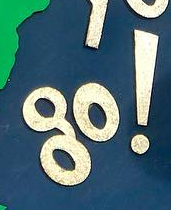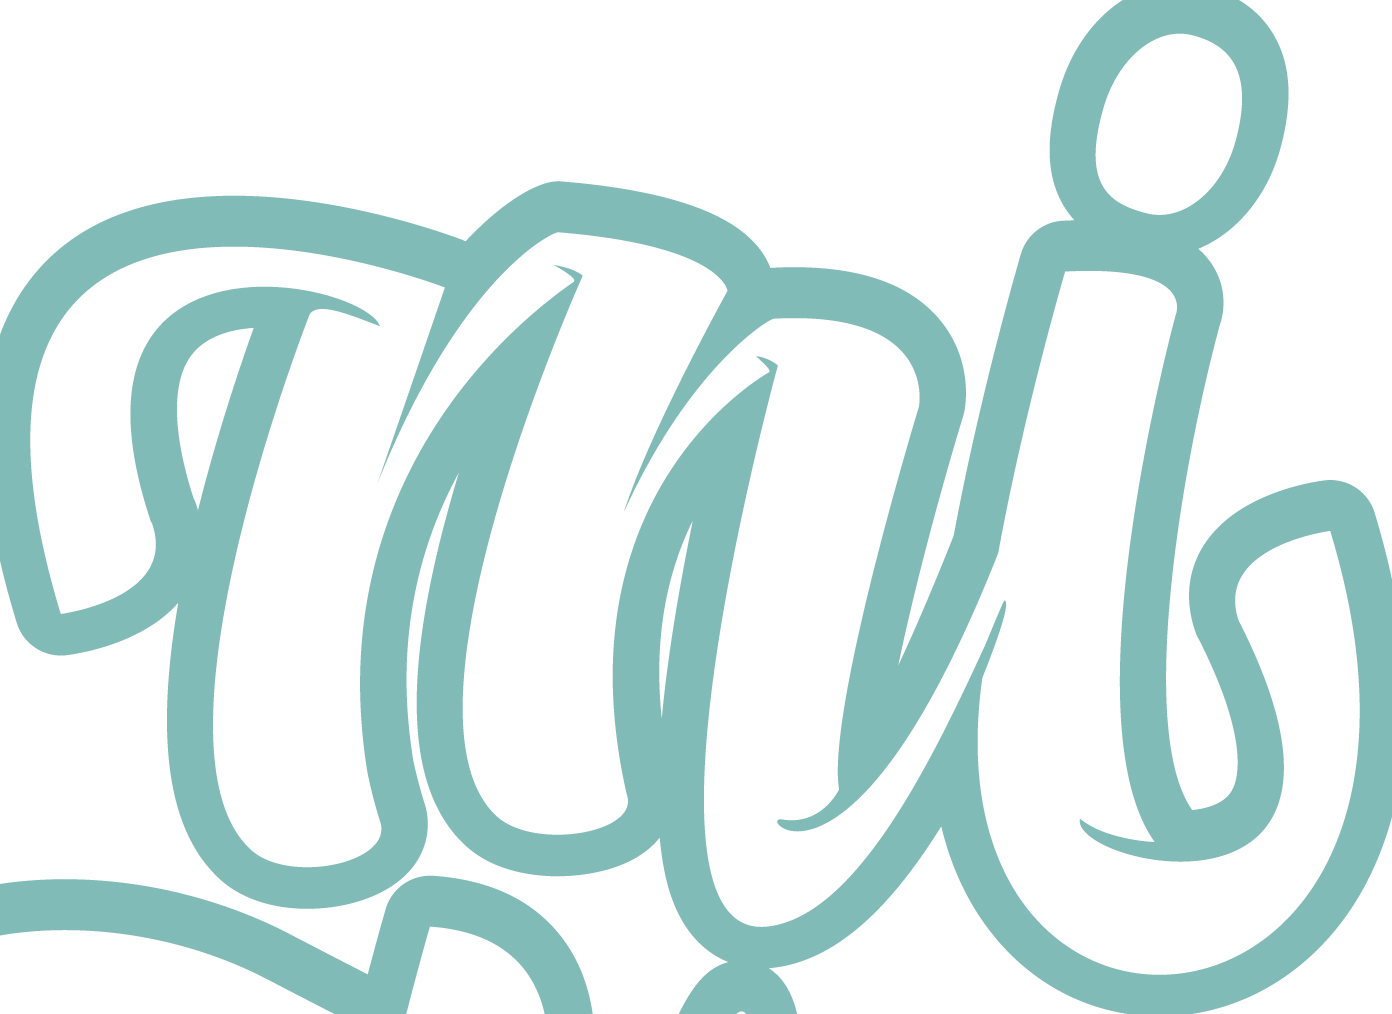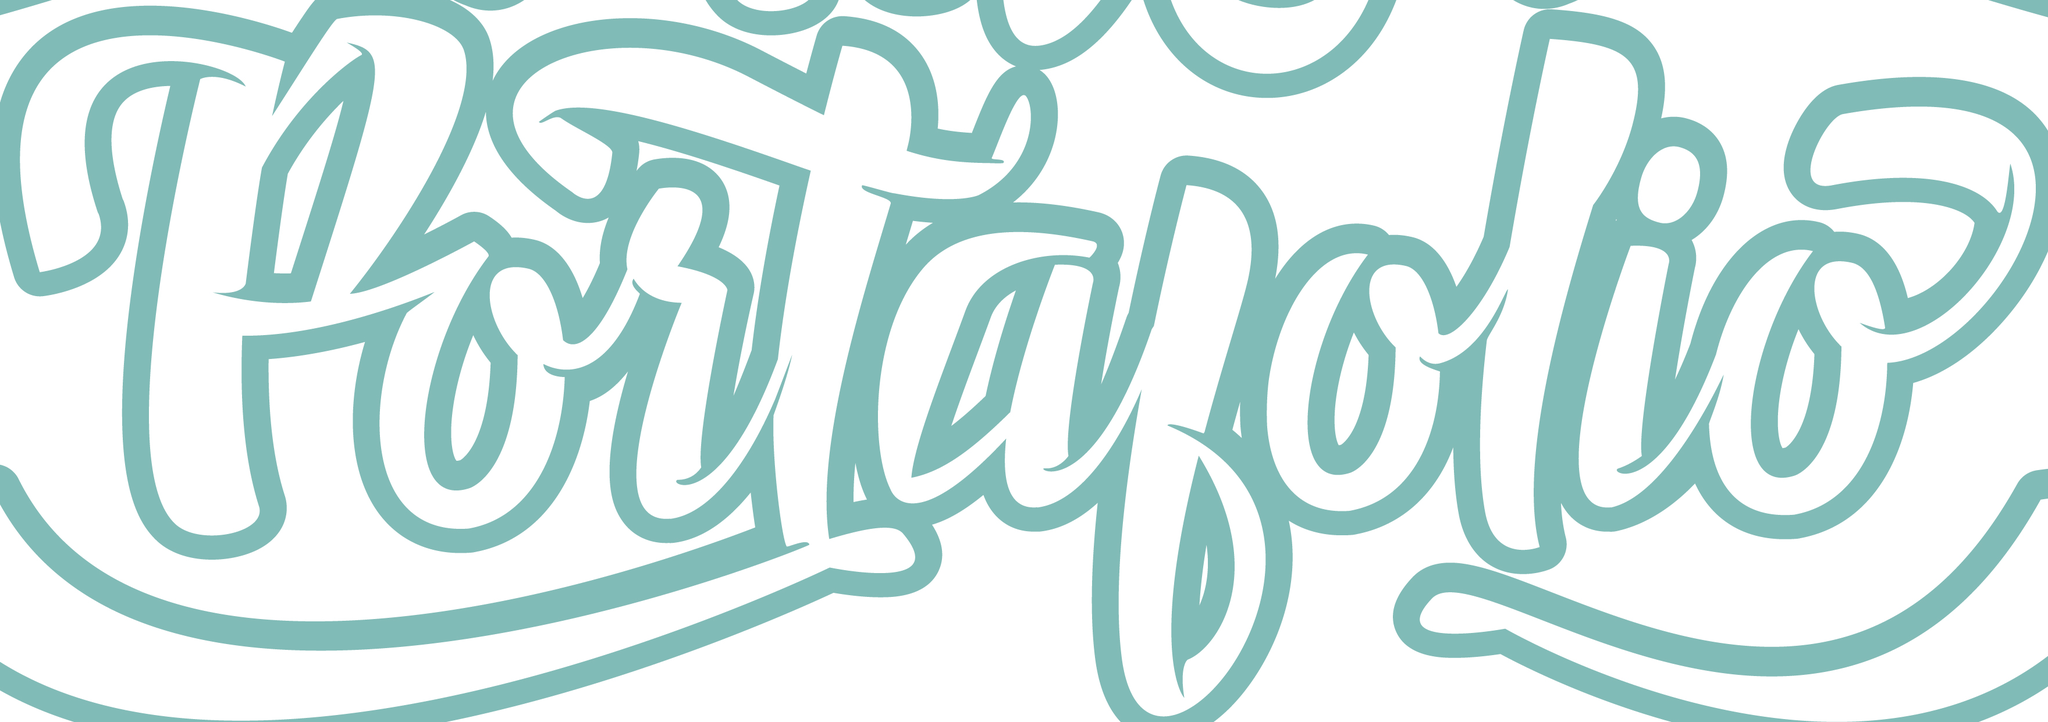Read the text content from these images in order, separated by a semicolon. go!; mi; portalolio 